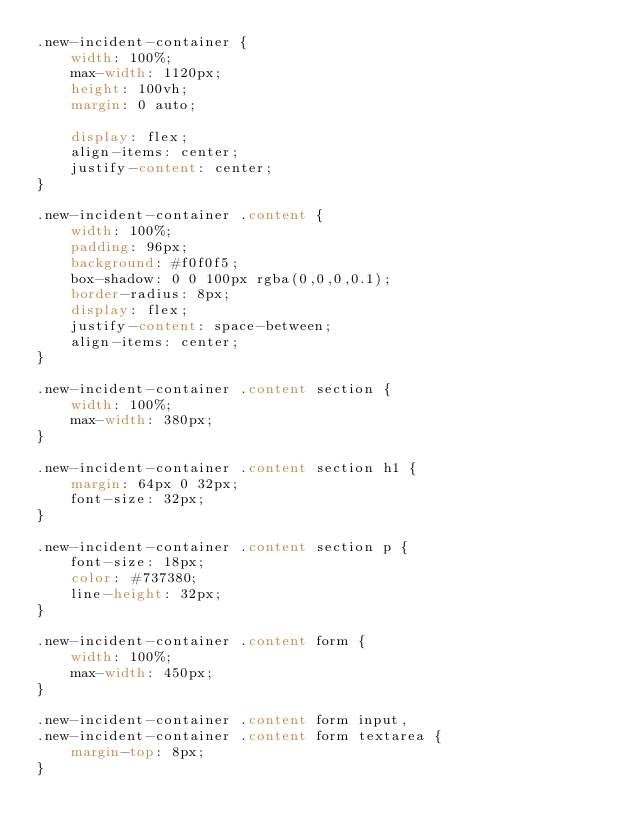<code> <loc_0><loc_0><loc_500><loc_500><_CSS_>.new-incident-container {
    width: 100%;
    max-width: 1120px;
    height: 100vh;
    margin: 0 auto;

    display: flex;
    align-items: center;
    justify-content: center;
}

.new-incident-container .content {
    width: 100%;
    padding: 96px;
    background: #f0f0f5;
    box-shadow: 0 0 100px rgba(0,0,0,0.1);
    border-radius: 8px;
    display: flex;
    justify-content: space-between;
    align-items: center;
}

.new-incident-container .content section {
    width: 100%;
    max-width: 380px;
}

.new-incident-container .content section h1 {
    margin: 64px 0 32px;
    font-size: 32px;
}

.new-incident-container .content section p {
    font-size: 18px;
    color: #737380;
    line-height: 32px;
}

.new-incident-container .content form {
    width: 100%;
    max-width: 450px;
}

.new-incident-container .content form input,
.new-incident-container .content form textarea {
    margin-top: 8px;
}</code> 